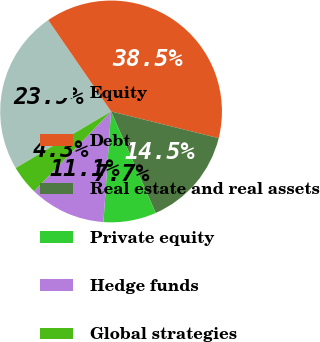Convert chart. <chart><loc_0><loc_0><loc_500><loc_500><pie_chart><fcel>Equity<fcel>Debt<fcel>Real estate and real assets<fcel>Private equity<fcel>Hedge funds<fcel>Global strategies<nl><fcel>23.93%<fcel>38.46%<fcel>14.53%<fcel>7.69%<fcel>11.11%<fcel>4.27%<nl></chart> 